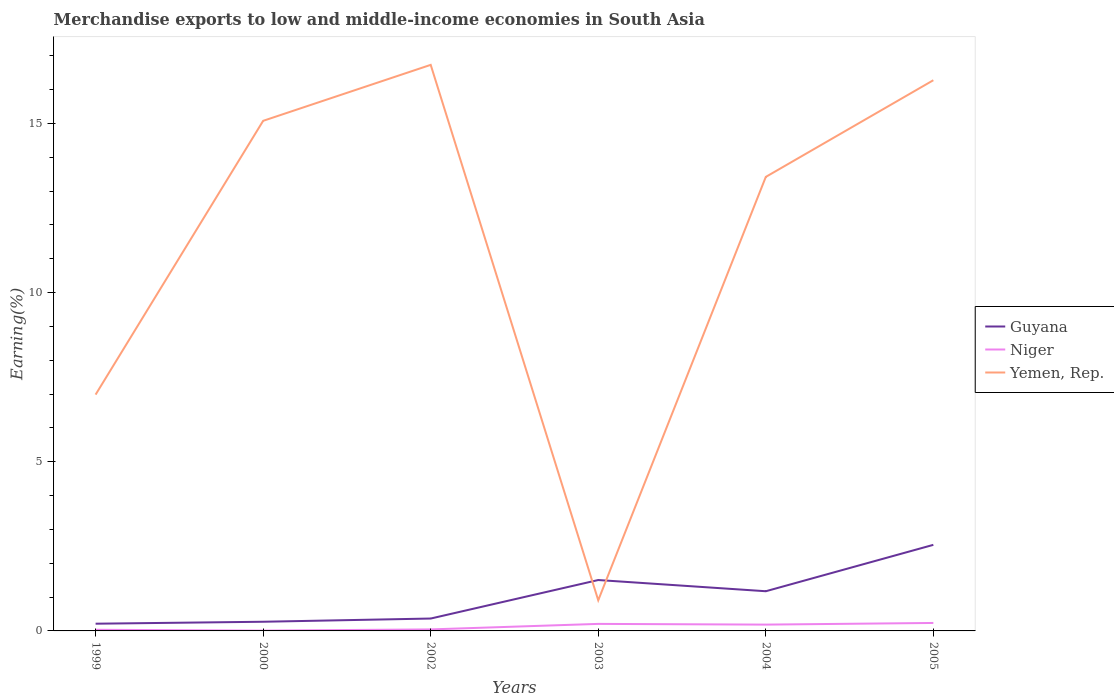Does the line corresponding to Guyana intersect with the line corresponding to Niger?
Provide a succinct answer. No. Is the number of lines equal to the number of legend labels?
Offer a terse response. Yes. Across all years, what is the maximum percentage of amount earned from merchandise exports in Guyana?
Your response must be concise. 0.21. In which year was the percentage of amount earned from merchandise exports in Guyana maximum?
Provide a succinct answer. 1999. What is the total percentage of amount earned from merchandise exports in Yemen, Rep. in the graph?
Make the answer very short. 3.31. What is the difference between the highest and the second highest percentage of amount earned from merchandise exports in Guyana?
Your response must be concise. 2.33. What is the difference between the highest and the lowest percentage of amount earned from merchandise exports in Yemen, Rep.?
Your answer should be very brief. 4. Is the percentage of amount earned from merchandise exports in Yemen, Rep. strictly greater than the percentage of amount earned from merchandise exports in Niger over the years?
Keep it short and to the point. No. What is the difference between two consecutive major ticks on the Y-axis?
Provide a short and direct response. 5. Are the values on the major ticks of Y-axis written in scientific E-notation?
Your response must be concise. No. Does the graph contain any zero values?
Your answer should be compact. No. How many legend labels are there?
Your answer should be very brief. 3. How are the legend labels stacked?
Give a very brief answer. Vertical. What is the title of the graph?
Provide a succinct answer. Merchandise exports to low and middle-income economies in South Asia. Does "Faeroe Islands" appear as one of the legend labels in the graph?
Your response must be concise. No. What is the label or title of the Y-axis?
Your answer should be very brief. Earning(%). What is the Earning(%) in Guyana in 1999?
Give a very brief answer. 0.21. What is the Earning(%) in Niger in 1999?
Provide a succinct answer. 0.03. What is the Earning(%) of Yemen, Rep. in 1999?
Offer a very short reply. 6.98. What is the Earning(%) in Guyana in 2000?
Ensure brevity in your answer.  0.27. What is the Earning(%) in Niger in 2000?
Offer a terse response. 0.01. What is the Earning(%) in Yemen, Rep. in 2000?
Make the answer very short. 15.08. What is the Earning(%) in Guyana in 2002?
Provide a succinct answer. 0.37. What is the Earning(%) in Niger in 2002?
Provide a succinct answer. 0.04. What is the Earning(%) in Yemen, Rep. in 2002?
Offer a terse response. 16.73. What is the Earning(%) in Guyana in 2003?
Give a very brief answer. 1.5. What is the Earning(%) in Niger in 2003?
Give a very brief answer. 0.21. What is the Earning(%) in Yemen, Rep. in 2003?
Ensure brevity in your answer.  0.91. What is the Earning(%) in Guyana in 2004?
Provide a short and direct response. 1.17. What is the Earning(%) in Niger in 2004?
Offer a terse response. 0.19. What is the Earning(%) in Yemen, Rep. in 2004?
Provide a succinct answer. 13.42. What is the Earning(%) of Guyana in 2005?
Make the answer very short. 2.54. What is the Earning(%) of Niger in 2005?
Offer a terse response. 0.24. What is the Earning(%) in Yemen, Rep. in 2005?
Keep it short and to the point. 16.28. Across all years, what is the maximum Earning(%) of Guyana?
Give a very brief answer. 2.54. Across all years, what is the maximum Earning(%) of Niger?
Provide a succinct answer. 0.24. Across all years, what is the maximum Earning(%) of Yemen, Rep.?
Offer a very short reply. 16.73. Across all years, what is the minimum Earning(%) in Guyana?
Give a very brief answer. 0.21. Across all years, what is the minimum Earning(%) of Niger?
Your answer should be very brief. 0.01. Across all years, what is the minimum Earning(%) in Yemen, Rep.?
Ensure brevity in your answer.  0.91. What is the total Earning(%) of Guyana in the graph?
Offer a terse response. 6.07. What is the total Earning(%) of Niger in the graph?
Give a very brief answer. 0.72. What is the total Earning(%) in Yemen, Rep. in the graph?
Your response must be concise. 69.39. What is the difference between the Earning(%) of Guyana in 1999 and that in 2000?
Keep it short and to the point. -0.06. What is the difference between the Earning(%) of Niger in 1999 and that in 2000?
Offer a very short reply. 0.02. What is the difference between the Earning(%) of Yemen, Rep. in 1999 and that in 2000?
Your answer should be compact. -8.09. What is the difference between the Earning(%) in Guyana in 1999 and that in 2002?
Your answer should be compact. -0.15. What is the difference between the Earning(%) of Niger in 1999 and that in 2002?
Your answer should be very brief. -0.01. What is the difference between the Earning(%) of Yemen, Rep. in 1999 and that in 2002?
Your answer should be very brief. -9.75. What is the difference between the Earning(%) of Guyana in 1999 and that in 2003?
Offer a terse response. -1.29. What is the difference between the Earning(%) in Niger in 1999 and that in 2003?
Your response must be concise. -0.17. What is the difference between the Earning(%) of Yemen, Rep. in 1999 and that in 2003?
Offer a very short reply. 6.08. What is the difference between the Earning(%) of Guyana in 1999 and that in 2004?
Make the answer very short. -0.96. What is the difference between the Earning(%) in Niger in 1999 and that in 2004?
Make the answer very short. -0.15. What is the difference between the Earning(%) of Yemen, Rep. in 1999 and that in 2004?
Your response must be concise. -6.43. What is the difference between the Earning(%) of Guyana in 1999 and that in 2005?
Your response must be concise. -2.33. What is the difference between the Earning(%) in Niger in 1999 and that in 2005?
Your answer should be compact. -0.2. What is the difference between the Earning(%) in Yemen, Rep. in 1999 and that in 2005?
Keep it short and to the point. -9.29. What is the difference between the Earning(%) of Guyana in 2000 and that in 2002?
Provide a succinct answer. -0.09. What is the difference between the Earning(%) of Niger in 2000 and that in 2002?
Offer a terse response. -0.04. What is the difference between the Earning(%) of Yemen, Rep. in 2000 and that in 2002?
Provide a succinct answer. -1.65. What is the difference between the Earning(%) of Guyana in 2000 and that in 2003?
Provide a short and direct response. -1.23. What is the difference between the Earning(%) of Niger in 2000 and that in 2003?
Provide a short and direct response. -0.2. What is the difference between the Earning(%) in Yemen, Rep. in 2000 and that in 2003?
Offer a terse response. 14.17. What is the difference between the Earning(%) in Guyana in 2000 and that in 2004?
Make the answer very short. -0.9. What is the difference between the Earning(%) of Niger in 2000 and that in 2004?
Make the answer very short. -0.18. What is the difference between the Earning(%) of Yemen, Rep. in 2000 and that in 2004?
Your response must be concise. 1.66. What is the difference between the Earning(%) in Guyana in 2000 and that in 2005?
Provide a short and direct response. -2.27. What is the difference between the Earning(%) of Niger in 2000 and that in 2005?
Your response must be concise. -0.23. What is the difference between the Earning(%) of Yemen, Rep. in 2000 and that in 2005?
Provide a succinct answer. -1.2. What is the difference between the Earning(%) of Guyana in 2002 and that in 2003?
Your answer should be very brief. -1.14. What is the difference between the Earning(%) of Niger in 2002 and that in 2003?
Keep it short and to the point. -0.16. What is the difference between the Earning(%) of Yemen, Rep. in 2002 and that in 2003?
Keep it short and to the point. 15.82. What is the difference between the Earning(%) in Guyana in 2002 and that in 2004?
Give a very brief answer. -0.81. What is the difference between the Earning(%) of Niger in 2002 and that in 2004?
Keep it short and to the point. -0.14. What is the difference between the Earning(%) of Yemen, Rep. in 2002 and that in 2004?
Provide a short and direct response. 3.31. What is the difference between the Earning(%) in Guyana in 2002 and that in 2005?
Give a very brief answer. -2.18. What is the difference between the Earning(%) of Niger in 2002 and that in 2005?
Your answer should be very brief. -0.19. What is the difference between the Earning(%) in Yemen, Rep. in 2002 and that in 2005?
Offer a very short reply. 0.45. What is the difference between the Earning(%) of Guyana in 2003 and that in 2004?
Make the answer very short. 0.33. What is the difference between the Earning(%) of Niger in 2003 and that in 2004?
Keep it short and to the point. 0.02. What is the difference between the Earning(%) of Yemen, Rep. in 2003 and that in 2004?
Keep it short and to the point. -12.51. What is the difference between the Earning(%) of Guyana in 2003 and that in 2005?
Your answer should be very brief. -1.04. What is the difference between the Earning(%) of Niger in 2003 and that in 2005?
Your response must be concise. -0.03. What is the difference between the Earning(%) of Yemen, Rep. in 2003 and that in 2005?
Make the answer very short. -15.37. What is the difference between the Earning(%) in Guyana in 2004 and that in 2005?
Provide a short and direct response. -1.37. What is the difference between the Earning(%) of Niger in 2004 and that in 2005?
Your response must be concise. -0.05. What is the difference between the Earning(%) of Yemen, Rep. in 2004 and that in 2005?
Provide a succinct answer. -2.86. What is the difference between the Earning(%) in Guyana in 1999 and the Earning(%) in Niger in 2000?
Your answer should be very brief. 0.2. What is the difference between the Earning(%) of Guyana in 1999 and the Earning(%) of Yemen, Rep. in 2000?
Give a very brief answer. -14.86. What is the difference between the Earning(%) in Niger in 1999 and the Earning(%) in Yemen, Rep. in 2000?
Ensure brevity in your answer.  -15.04. What is the difference between the Earning(%) of Guyana in 1999 and the Earning(%) of Niger in 2002?
Offer a terse response. 0.17. What is the difference between the Earning(%) in Guyana in 1999 and the Earning(%) in Yemen, Rep. in 2002?
Keep it short and to the point. -16.52. What is the difference between the Earning(%) in Niger in 1999 and the Earning(%) in Yemen, Rep. in 2002?
Your response must be concise. -16.7. What is the difference between the Earning(%) of Guyana in 1999 and the Earning(%) of Niger in 2003?
Your answer should be compact. 0.01. What is the difference between the Earning(%) in Guyana in 1999 and the Earning(%) in Yemen, Rep. in 2003?
Provide a short and direct response. -0.69. What is the difference between the Earning(%) of Niger in 1999 and the Earning(%) of Yemen, Rep. in 2003?
Make the answer very short. -0.87. What is the difference between the Earning(%) in Guyana in 1999 and the Earning(%) in Niger in 2004?
Give a very brief answer. 0.03. What is the difference between the Earning(%) in Guyana in 1999 and the Earning(%) in Yemen, Rep. in 2004?
Offer a very short reply. -13.21. What is the difference between the Earning(%) in Niger in 1999 and the Earning(%) in Yemen, Rep. in 2004?
Keep it short and to the point. -13.39. What is the difference between the Earning(%) of Guyana in 1999 and the Earning(%) of Niger in 2005?
Provide a succinct answer. -0.02. What is the difference between the Earning(%) in Guyana in 1999 and the Earning(%) in Yemen, Rep. in 2005?
Give a very brief answer. -16.06. What is the difference between the Earning(%) of Niger in 1999 and the Earning(%) of Yemen, Rep. in 2005?
Make the answer very short. -16.24. What is the difference between the Earning(%) of Guyana in 2000 and the Earning(%) of Niger in 2002?
Your response must be concise. 0.23. What is the difference between the Earning(%) in Guyana in 2000 and the Earning(%) in Yemen, Rep. in 2002?
Offer a very short reply. -16.46. What is the difference between the Earning(%) of Niger in 2000 and the Earning(%) of Yemen, Rep. in 2002?
Offer a terse response. -16.72. What is the difference between the Earning(%) of Guyana in 2000 and the Earning(%) of Niger in 2003?
Your answer should be compact. 0.06. What is the difference between the Earning(%) in Guyana in 2000 and the Earning(%) in Yemen, Rep. in 2003?
Provide a succinct answer. -0.63. What is the difference between the Earning(%) in Niger in 2000 and the Earning(%) in Yemen, Rep. in 2003?
Give a very brief answer. -0.9. What is the difference between the Earning(%) of Guyana in 2000 and the Earning(%) of Niger in 2004?
Offer a very short reply. 0.08. What is the difference between the Earning(%) of Guyana in 2000 and the Earning(%) of Yemen, Rep. in 2004?
Offer a very short reply. -13.15. What is the difference between the Earning(%) of Niger in 2000 and the Earning(%) of Yemen, Rep. in 2004?
Ensure brevity in your answer.  -13.41. What is the difference between the Earning(%) of Guyana in 2000 and the Earning(%) of Niger in 2005?
Your answer should be compact. 0.04. What is the difference between the Earning(%) in Guyana in 2000 and the Earning(%) in Yemen, Rep. in 2005?
Give a very brief answer. -16.01. What is the difference between the Earning(%) of Niger in 2000 and the Earning(%) of Yemen, Rep. in 2005?
Make the answer very short. -16.27. What is the difference between the Earning(%) in Guyana in 2002 and the Earning(%) in Niger in 2003?
Provide a succinct answer. 0.16. What is the difference between the Earning(%) of Guyana in 2002 and the Earning(%) of Yemen, Rep. in 2003?
Give a very brief answer. -0.54. What is the difference between the Earning(%) of Niger in 2002 and the Earning(%) of Yemen, Rep. in 2003?
Your response must be concise. -0.86. What is the difference between the Earning(%) of Guyana in 2002 and the Earning(%) of Niger in 2004?
Provide a short and direct response. 0.18. What is the difference between the Earning(%) of Guyana in 2002 and the Earning(%) of Yemen, Rep. in 2004?
Keep it short and to the point. -13.05. What is the difference between the Earning(%) of Niger in 2002 and the Earning(%) of Yemen, Rep. in 2004?
Provide a short and direct response. -13.37. What is the difference between the Earning(%) of Guyana in 2002 and the Earning(%) of Niger in 2005?
Keep it short and to the point. 0.13. What is the difference between the Earning(%) of Guyana in 2002 and the Earning(%) of Yemen, Rep. in 2005?
Make the answer very short. -15.91. What is the difference between the Earning(%) in Niger in 2002 and the Earning(%) in Yemen, Rep. in 2005?
Your response must be concise. -16.23. What is the difference between the Earning(%) in Guyana in 2003 and the Earning(%) in Niger in 2004?
Your answer should be compact. 1.32. What is the difference between the Earning(%) in Guyana in 2003 and the Earning(%) in Yemen, Rep. in 2004?
Your answer should be compact. -11.91. What is the difference between the Earning(%) in Niger in 2003 and the Earning(%) in Yemen, Rep. in 2004?
Provide a succinct answer. -13.21. What is the difference between the Earning(%) of Guyana in 2003 and the Earning(%) of Niger in 2005?
Give a very brief answer. 1.27. What is the difference between the Earning(%) in Guyana in 2003 and the Earning(%) in Yemen, Rep. in 2005?
Your answer should be very brief. -14.77. What is the difference between the Earning(%) of Niger in 2003 and the Earning(%) of Yemen, Rep. in 2005?
Make the answer very short. -16.07. What is the difference between the Earning(%) in Guyana in 2004 and the Earning(%) in Niger in 2005?
Your answer should be very brief. 0.94. What is the difference between the Earning(%) in Guyana in 2004 and the Earning(%) in Yemen, Rep. in 2005?
Your response must be concise. -15.1. What is the difference between the Earning(%) of Niger in 2004 and the Earning(%) of Yemen, Rep. in 2005?
Offer a terse response. -16.09. What is the average Earning(%) in Guyana per year?
Provide a succinct answer. 1.01. What is the average Earning(%) in Niger per year?
Give a very brief answer. 0.12. What is the average Earning(%) of Yemen, Rep. per year?
Give a very brief answer. 11.57. In the year 1999, what is the difference between the Earning(%) in Guyana and Earning(%) in Niger?
Give a very brief answer. 0.18. In the year 1999, what is the difference between the Earning(%) of Guyana and Earning(%) of Yemen, Rep.?
Ensure brevity in your answer.  -6.77. In the year 1999, what is the difference between the Earning(%) of Niger and Earning(%) of Yemen, Rep.?
Offer a very short reply. -6.95. In the year 2000, what is the difference between the Earning(%) in Guyana and Earning(%) in Niger?
Provide a succinct answer. 0.26. In the year 2000, what is the difference between the Earning(%) in Guyana and Earning(%) in Yemen, Rep.?
Ensure brevity in your answer.  -14.81. In the year 2000, what is the difference between the Earning(%) in Niger and Earning(%) in Yemen, Rep.?
Your answer should be very brief. -15.07. In the year 2002, what is the difference between the Earning(%) in Guyana and Earning(%) in Niger?
Your answer should be very brief. 0.32. In the year 2002, what is the difference between the Earning(%) in Guyana and Earning(%) in Yemen, Rep.?
Offer a very short reply. -16.36. In the year 2002, what is the difference between the Earning(%) of Niger and Earning(%) of Yemen, Rep.?
Keep it short and to the point. -16.69. In the year 2003, what is the difference between the Earning(%) in Guyana and Earning(%) in Niger?
Offer a terse response. 1.3. In the year 2003, what is the difference between the Earning(%) of Guyana and Earning(%) of Yemen, Rep.?
Your response must be concise. 0.6. In the year 2003, what is the difference between the Earning(%) of Niger and Earning(%) of Yemen, Rep.?
Keep it short and to the point. -0.7. In the year 2004, what is the difference between the Earning(%) of Guyana and Earning(%) of Niger?
Keep it short and to the point. 0.99. In the year 2004, what is the difference between the Earning(%) of Guyana and Earning(%) of Yemen, Rep.?
Give a very brief answer. -12.25. In the year 2004, what is the difference between the Earning(%) in Niger and Earning(%) in Yemen, Rep.?
Keep it short and to the point. -13.23. In the year 2005, what is the difference between the Earning(%) of Guyana and Earning(%) of Niger?
Make the answer very short. 2.31. In the year 2005, what is the difference between the Earning(%) of Guyana and Earning(%) of Yemen, Rep.?
Offer a terse response. -13.73. In the year 2005, what is the difference between the Earning(%) of Niger and Earning(%) of Yemen, Rep.?
Ensure brevity in your answer.  -16.04. What is the ratio of the Earning(%) in Guyana in 1999 to that in 2000?
Make the answer very short. 0.79. What is the ratio of the Earning(%) of Niger in 1999 to that in 2000?
Provide a short and direct response. 3.61. What is the ratio of the Earning(%) in Yemen, Rep. in 1999 to that in 2000?
Provide a short and direct response. 0.46. What is the ratio of the Earning(%) in Guyana in 1999 to that in 2002?
Give a very brief answer. 0.58. What is the ratio of the Earning(%) of Niger in 1999 to that in 2002?
Keep it short and to the point. 0.75. What is the ratio of the Earning(%) in Yemen, Rep. in 1999 to that in 2002?
Ensure brevity in your answer.  0.42. What is the ratio of the Earning(%) of Guyana in 1999 to that in 2003?
Provide a succinct answer. 0.14. What is the ratio of the Earning(%) in Niger in 1999 to that in 2003?
Provide a succinct answer. 0.16. What is the ratio of the Earning(%) in Yemen, Rep. in 1999 to that in 2003?
Provide a succinct answer. 7.71. What is the ratio of the Earning(%) in Guyana in 1999 to that in 2004?
Ensure brevity in your answer.  0.18. What is the ratio of the Earning(%) of Niger in 1999 to that in 2004?
Give a very brief answer. 0.18. What is the ratio of the Earning(%) of Yemen, Rep. in 1999 to that in 2004?
Provide a short and direct response. 0.52. What is the ratio of the Earning(%) in Guyana in 1999 to that in 2005?
Your answer should be very brief. 0.08. What is the ratio of the Earning(%) of Niger in 1999 to that in 2005?
Provide a succinct answer. 0.14. What is the ratio of the Earning(%) of Yemen, Rep. in 1999 to that in 2005?
Offer a terse response. 0.43. What is the ratio of the Earning(%) in Guyana in 2000 to that in 2002?
Your answer should be compact. 0.74. What is the ratio of the Earning(%) of Niger in 2000 to that in 2002?
Provide a short and direct response. 0.21. What is the ratio of the Earning(%) in Yemen, Rep. in 2000 to that in 2002?
Your answer should be very brief. 0.9. What is the ratio of the Earning(%) of Guyana in 2000 to that in 2003?
Provide a short and direct response. 0.18. What is the ratio of the Earning(%) of Niger in 2000 to that in 2003?
Provide a succinct answer. 0.04. What is the ratio of the Earning(%) of Yemen, Rep. in 2000 to that in 2003?
Your answer should be very brief. 16.64. What is the ratio of the Earning(%) of Guyana in 2000 to that in 2004?
Your response must be concise. 0.23. What is the ratio of the Earning(%) of Niger in 2000 to that in 2004?
Keep it short and to the point. 0.05. What is the ratio of the Earning(%) in Yemen, Rep. in 2000 to that in 2004?
Your answer should be compact. 1.12. What is the ratio of the Earning(%) of Guyana in 2000 to that in 2005?
Your answer should be compact. 0.11. What is the ratio of the Earning(%) of Niger in 2000 to that in 2005?
Offer a very short reply. 0.04. What is the ratio of the Earning(%) of Yemen, Rep. in 2000 to that in 2005?
Your answer should be very brief. 0.93. What is the ratio of the Earning(%) of Guyana in 2002 to that in 2003?
Give a very brief answer. 0.24. What is the ratio of the Earning(%) of Niger in 2002 to that in 2003?
Provide a succinct answer. 0.22. What is the ratio of the Earning(%) of Yemen, Rep. in 2002 to that in 2003?
Make the answer very short. 18.47. What is the ratio of the Earning(%) in Guyana in 2002 to that in 2004?
Keep it short and to the point. 0.31. What is the ratio of the Earning(%) in Niger in 2002 to that in 2004?
Keep it short and to the point. 0.24. What is the ratio of the Earning(%) of Yemen, Rep. in 2002 to that in 2004?
Provide a short and direct response. 1.25. What is the ratio of the Earning(%) in Guyana in 2002 to that in 2005?
Offer a very short reply. 0.14. What is the ratio of the Earning(%) of Niger in 2002 to that in 2005?
Keep it short and to the point. 0.19. What is the ratio of the Earning(%) in Yemen, Rep. in 2002 to that in 2005?
Your answer should be very brief. 1.03. What is the ratio of the Earning(%) of Guyana in 2003 to that in 2004?
Provide a succinct answer. 1.28. What is the ratio of the Earning(%) in Niger in 2003 to that in 2004?
Give a very brief answer. 1.11. What is the ratio of the Earning(%) in Yemen, Rep. in 2003 to that in 2004?
Provide a short and direct response. 0.07. What is the ratio of the Earning(%) of Guyana in 2003 to that in 2005?
Give a very brief answer. 0.59. What is the ratio of the Earning(%) of Niger in 2003 to that in 2005?
Provide a succinct answer. 0.88. What is the ratio of the Earning(%) in Yemen, Rep. in 2003 to that in 2005?
Your answer should be very brief. 0.06. What is the ratio of the Earning(%) in Guyana in 2004 to that in 2005?
Provide a succinct answer. 0.46. What is the ratio of the Earning(%) of Niger in 2004 to that in 2005?
Your answer should be very brief. 0.79. What is the ratio of the Earning(%) of Yemen, Rep. in 2004 to that in 2005?
Your answer should be compact. 0.82. What is the difference between the highest and the second highest Earning(%) in Guyana?
Make the answer very short. 1.04. What is the difference between the highest and the second highest Earning(%) of Niger?
Give a very brief answer. 0.03. What is the difference between the highest and the second highest Earning(%) in Yemen, Rep.?
Your response must be concise. 0.45. What is the difference between the highest and the lowest Earning(%) in Guyana?
Provide a succinct answer. 2.33. What is the difference between the highest and the lowest Earning(%) in Niger?
Provide a succinct answer. 0.23. What is the difference between the highest and the lowest Earning(%) of Yemen, Rep.?
Keep it short and to the point. 15.82. 